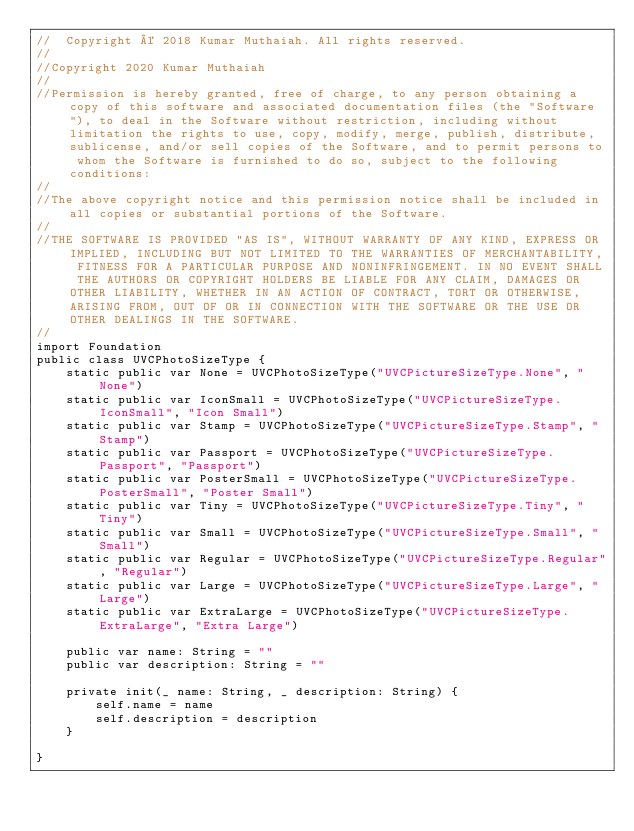Convert code to text. <code><loc_0><loc_0><loc_500><loc_500><_Swift_>//  Copyright © 2018 Kumar Muthaiah. All rights reserved.
//
//Copyright 2020 Kumar Muthaiah
//
//Permission is hereby granted, free of charge, to any person obtaining a copy of this software and associated documentation files (the "Software"), to deal in the Software without restriction, including without limitation the rights to use, copy, modify, merge, publish, distribute, sublicense, and/or sell copies of the Software, and to permit persons to whom the Software is furnished to do so, subject to the following conditions:
//
//The above copyright notice and this permission notice shall be included in all copies or substantial portions of the Software.
//
//THE SOFTWARE IS PROVIDED "AS IS", WITHOUT WARRANTY OF ANY KIND, EXPRESS OR IMPLIED, INCLUDING BUT NOT LIMITED TO THE WARRANTIES OF MERCHANTABILITY, FITNESS FOR A PARTICULAR PURPOSE AND NONINFRINGEMENT. IN NO EVENT SHALL THE AUTHORS OR COPYRIGHT HOLDERS BE LIABLE FOR ANY CLAIM, DAMAGES OR OTHER LIABILITY, WHETHER IN AN ACTION OF CONTRACT, TORT OR OTHERWISE, ARISING FROM, OUT OF OR IN CONNECTION WITH THE SOFTWARE OR THE USE OR OTHER DEALINGS IN THE SOFTWARE.
//
import Foundation
public class UVCPhotoSizeType {
    static public var None = UVCPhotoSizeType("UVCPictureSizeType.None", "None")
    static public var IconSmall = UVCPhotoSizeType("UVCPictureSizeType.IconSmall", "Icon Small")
    static public var Stamp = UVCPhotoSizeType("UVCPictureSizeType.Stamp", "Stamp")
    static public var Passport = UVCPhotoSizeType("UVCPictureSizeType.Passport", "Passport")
    static public var PosterSmall = UVCPhotoSizeType("UVCPictureSizeType.PosterSmall", "Poster Small")
    static public var Tiny = UVCPhotoSizeType("UVCPictureSizeType.Tiny", "Tiny")
    static public var Small = UVCPhotoSizeType("UVCPictureSizeType.Small", "Small")
    static public var Regular = UVCPhotoSizeType("UVCPictureSizeType.Regular", "Regular")
    static public var Large = UVCPhotoSizeType("UVCPictureSizeType.Large", "Large")
    static public var ExtraLarge = UVCPhotoSizeType("UVCPictureSizeType.ExtraLarge", "Extra Large")

    public var name: String = ""
    public var description: String = ""
    
    private init(_ name: String, _ description: String) {
        self.name = name
        self.description = description
    }
    
}
</code> 